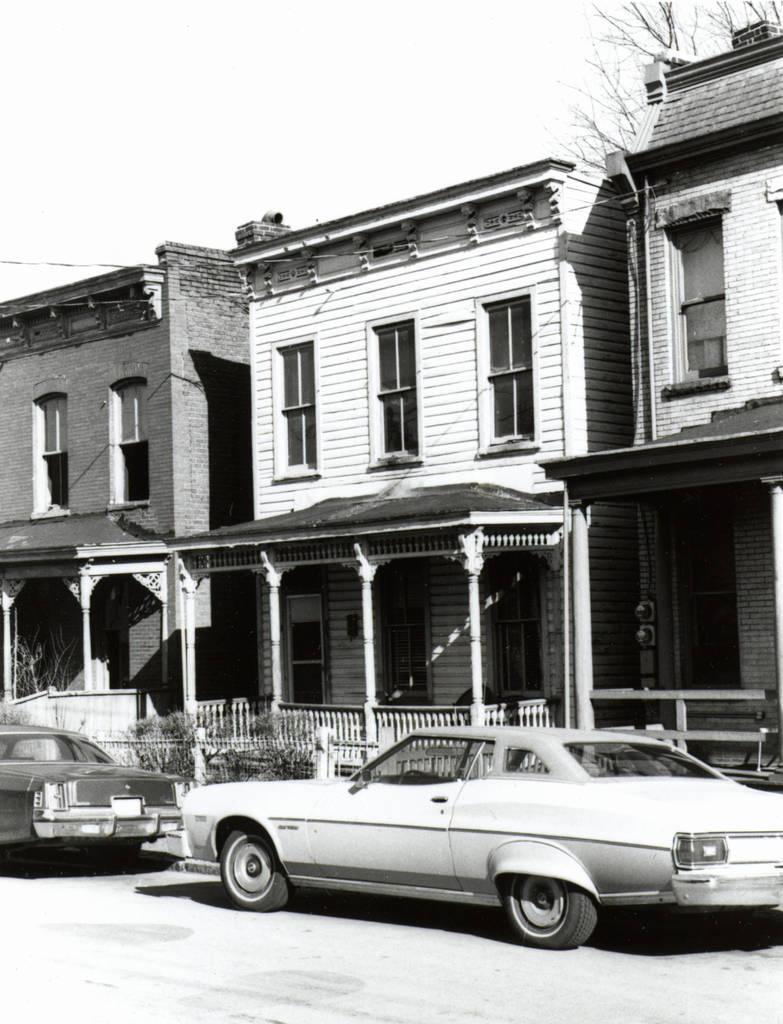In one or two sentences, can you explain what this image depicts? In this image few cars are on the road. Behind there are few plants. Behind it there is a fence. Background there are few buildings. Right top there is a tree. Top of the image there is sky. 